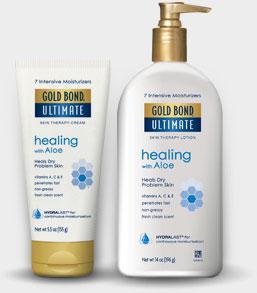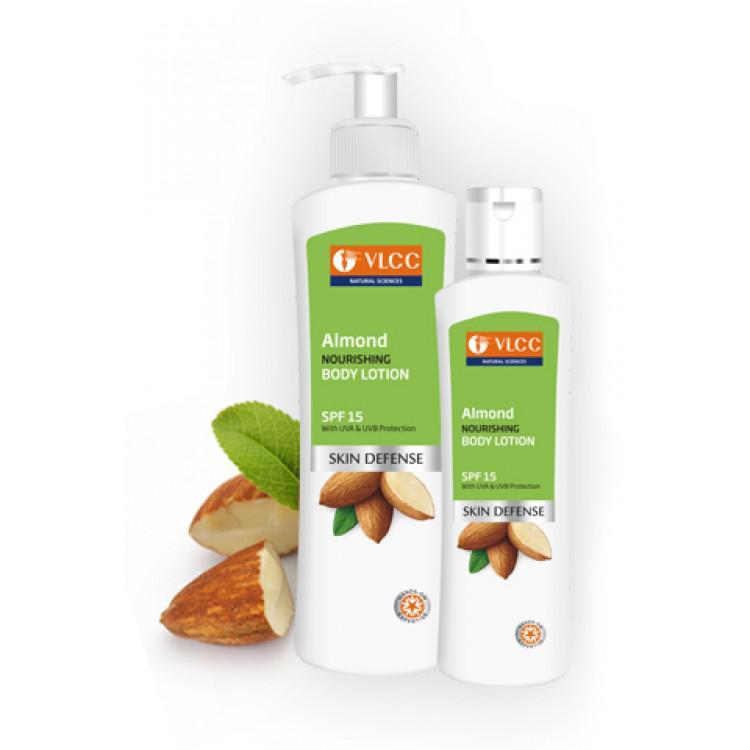The first image is the image on the left, the second image is the image on the right. Given the left and right images, does the statement "An image features two unwrapped pump bottles with nozzles turned rightward." hold true? Answer yes or no. No. The first image is the image on the left, the second image is the image on the right. Given the left and right images, does the statement "There are two dispensers pointing right in one of the images." hold true? Answer yes or no. No. 